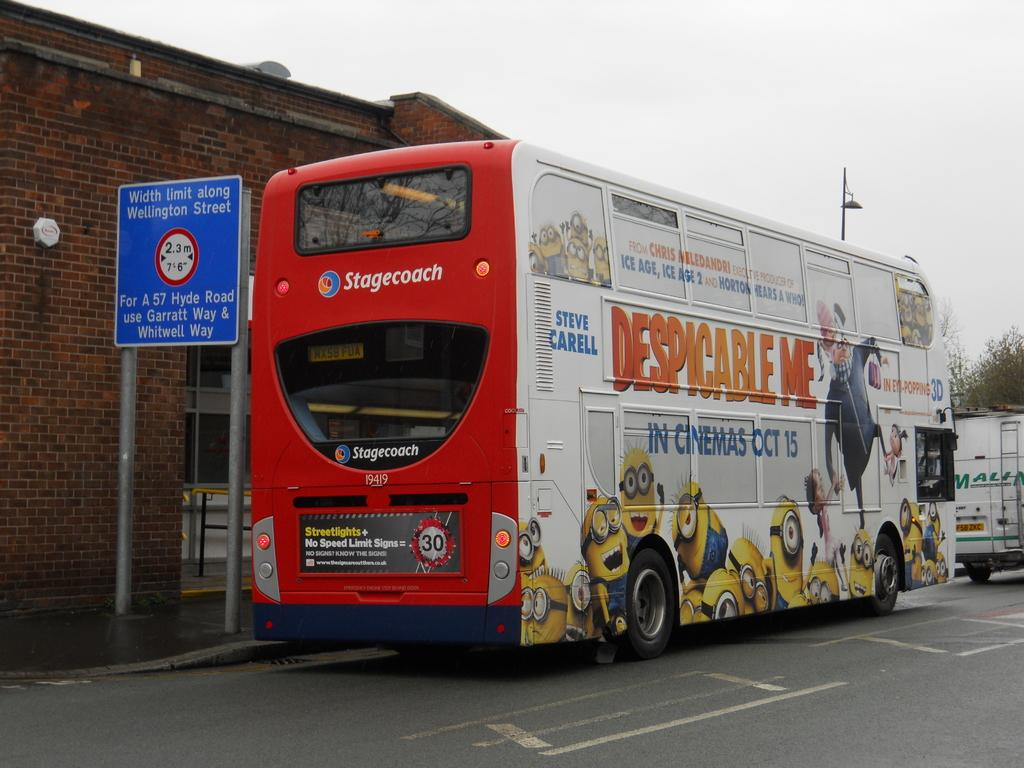What type of vehicle is in the image? There is a white and red color bus in the image. Where is the bus located? The bus is parked on the road. What can be seen in the background of the image? There is a red color brick wall and a blue color caution board in the background. What type of quilt is being used to cover the bus in the image? There is no quilt present in the image; it is a bus parked on the road with a brick wall and caution board in the background. 